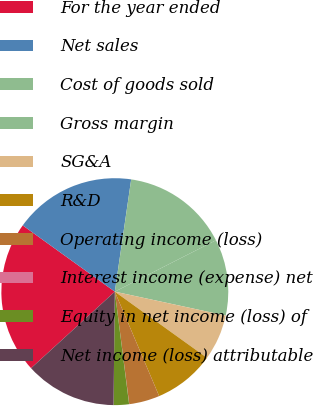<chart> <loc_0><loc_0><loc_500><loc_500><pie_chart><fcel>For the year ended<fcel>Net sales<fcel>Cost of goods sold<fcel>Gross margin<fcel>SG&A<fcel>R&D<fcel>Operating income (loss)<fcel>Interest income (expense) net<fcel>Equity in net income (loss) of<fcel>Net income (loss) attributable<nl><fcel>21.71%<fcel>17.38%<fcel>15.21%<fcel>10.87%<fcel>6.53%<fcel>8.7%<fcel>4.36%<fcel>0.02%<fcel>2.19%<fcel>13.04%<nl></chart> 